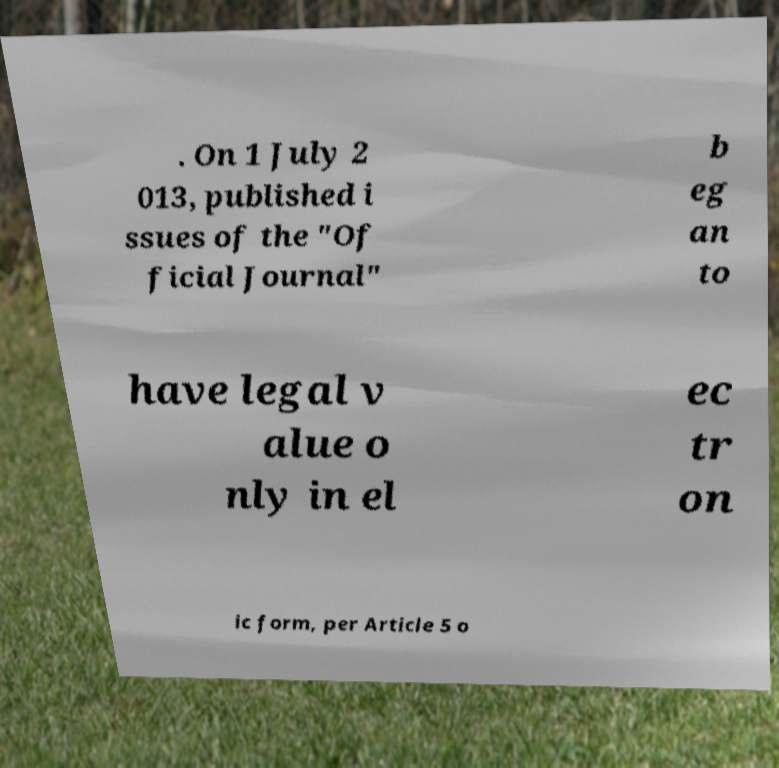Please identify and transcribe the text found in this image. . On 1 July 2 013, published i ssues of the "Of ficial Journal" b eg an to have legal v alue o nly in el ec tr on ic form, per Article 5 o 